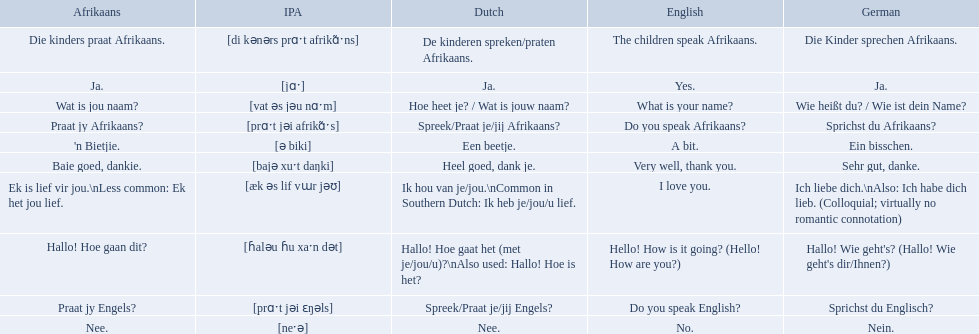How would you say the phrase the children speak afrikaans in afrikaans? Die kinders praat Afrikaans. How would you say the previous phrase in german? Die Kinder sprechen Afrikaans. 